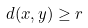<formula> <loc_0><loc_0><loc_500><loc_500>d ( x , y ) \geq r</formula> 